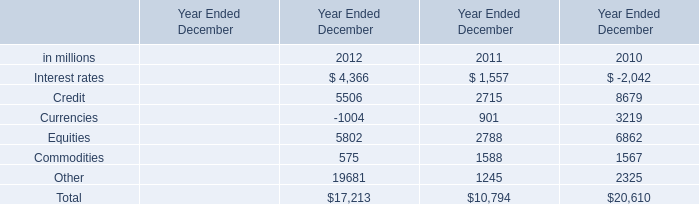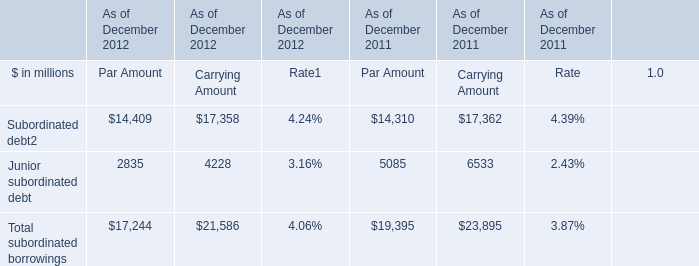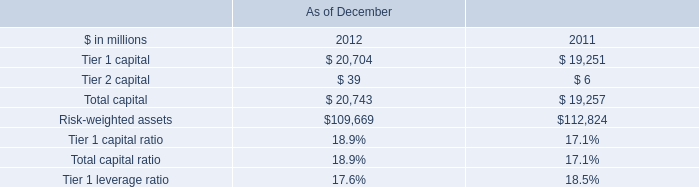What is the sum of Credit in 2010 and Junior subordinated debt of Par Amount in 2011? (in million) 
Computations: (8679 + 5085)
Answer: 13764.0. 